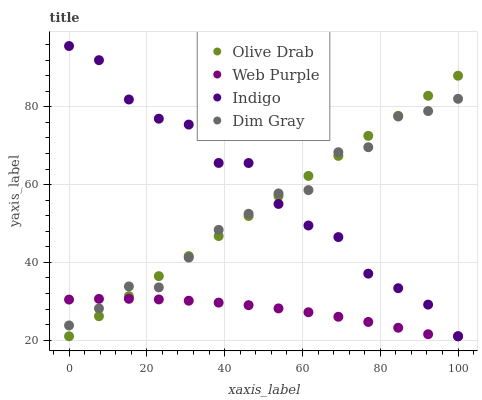Does Web Purple have the minimum area under the curve?
Answer yes or no. Yes. Does Indigo have the maximum area under the curve?
Answer yes or no. Yes. Does Dim Gray have the minimum area under the curve?
Answer yes or no. No. Does Dim Gray have the maximum area under the curve?
Answer yes or no. No. Is Olive Drab the smoothest?
Answer yes or no. Yes. Is Indigo the roughest?
Answer yes or no. Yes. Is Dim Gray the smoothest?
Answer yes or no. No. Is Dim Gray the roughest?
Answer yes or no. No. Does Web Purple have the lowest value?
Answer yes or no. Yes. Does Dim Gray have the lowest value?
Answer yes or no. No. Does Indigo have the highest value?
Answer yes or no. Yes. Does Dim Gray have the highest value?
Answer yes or no. No. Does Indigo intersect Olive Drab?
Answer yes or no. Yes. Is Indigo less than Olive Drab?
Answer yes or no. No. Is Indigo greater than Olive Drab?
Answer yes or no. No. 